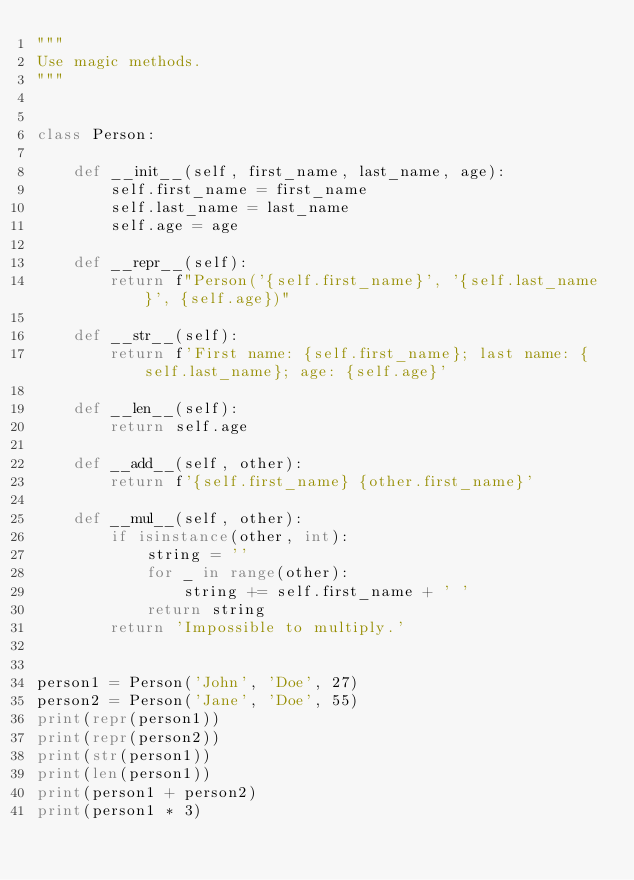<code> <loc_0><loc_0><loc_500><loc_500><_Python_>"""
Use magic methods.
"""


class Person:

    def __init__(self, first_name, last_name, age):
        self.first_name = first_name
        self.last_name = last_name
        self.age = age

    def __repr__(self):
        return f"Person('{self.first_name}', '{self.last_name}', {self.age})"

    def __str__(self):
        return f'First name: {self.first_name}; last name: {self.last_name}; age: {self.age}'

    def __len__(self):
        return self.age

    def __add__(self, other):
        return f'{self.first_name} {other.first_name}'

    def __mul__(self, other):
        if isinstance(other, int):
            string = ''
            for _ in range(other):
                string += self.first_name + ' '
            return string
        return 'Impossible to multiply.'


person1 = Person('John', 'Doe', 27)
person2 = Person('Jane', 'Doe', 55)
print(repr(person1))
print(repr(person2))
print(str(person1))
print(len(person1))
print(person1 + person2)
print(person1 * 3)
</code> 